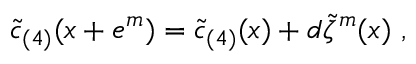<formula> <loc_0><loc_0><loc_500><loc_500>\tilde { c } _ { ( 4 ) } ( x + e ^ { m } ) = \tilde { c } _ { ( 4 ) } ( x ) + d \tilde { \zeta } ^ { m } ( x ) \ ,</formula> 